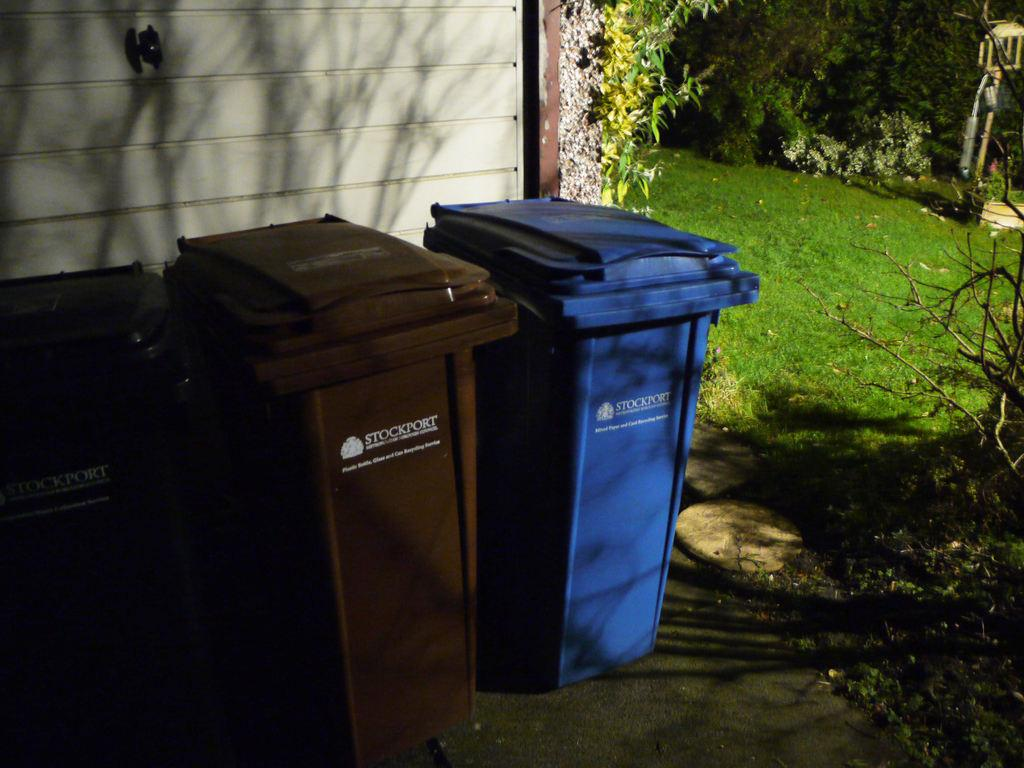<image>
Present a compact description of the photo's key features. A brown and blue trashcan that is made by the company Stockport. 